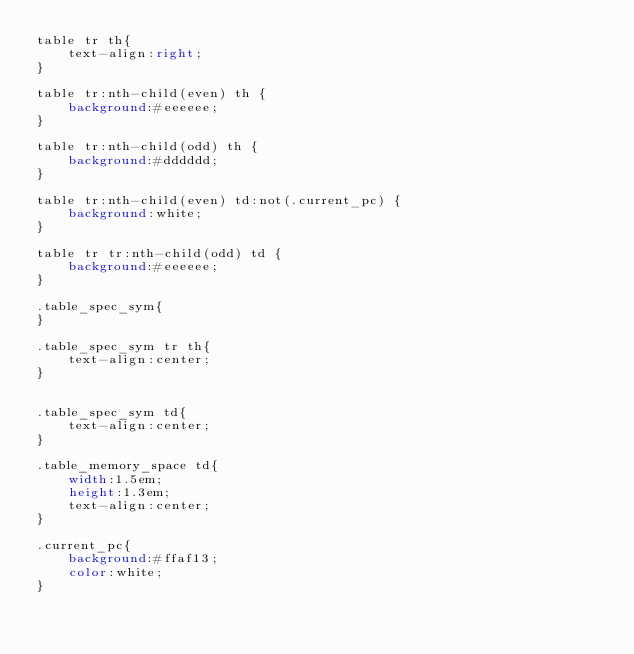<code> <loc_0><loc_0><loc_500><loc_500><_CSS_>table tr th{
    text-align:right;
}

table tr:nth-child(even) th {
    background:#eeeeee;
}

table tr:nth-child(odd) th {
    background:#dddddd;
}

table tr:nth-child(even) td:not(.current_pc) {
    background:white;
}

table tr tr:nth-child(odd) td {
    background:#eeeeee;
}

.table_spec_sym{
}

.table_spec_sym tr th{
    text-align:center;
}


.table_spec_sym td{
    text-align:center;
}

.table_memory_space td{
    width:1.5em;
    height:1.3em;
    text-align:center;
}

.current_pc{
    background:#ffaf13;
    color:white;
}


</code> 